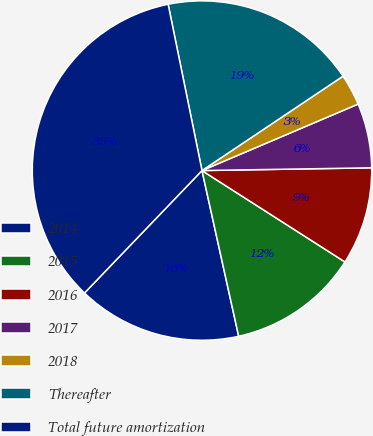Convert chart to OTSL. <chart><loc_0><loc_0><loc_500><loc_500><pie_chart><fcel>2014<fcel>2015<fcel>2016<fcel>2017<fcel>2018<fcel>Thereafter<fcel>Total future amortization<nl><fcel>15.64%<fcel>12.48%<fcel>9.31%<fcel>6.15%<fcel>2.98%<fcel>18.81%<fcel>34.63%<nl></chart> 